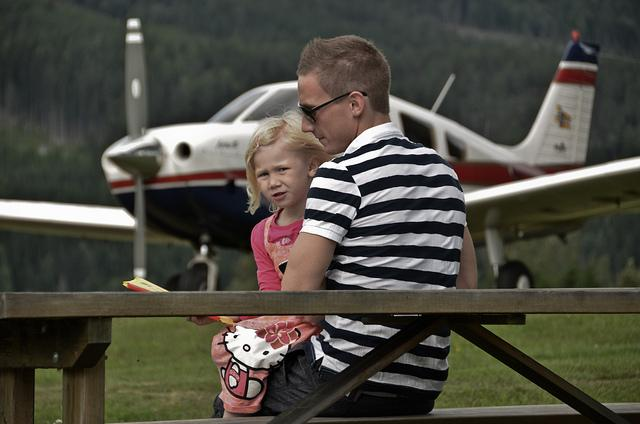What is the thing on the front tip of the airplane?

Choices:
A) whirl
B) tip
C) windmill
D) propeller propeller 